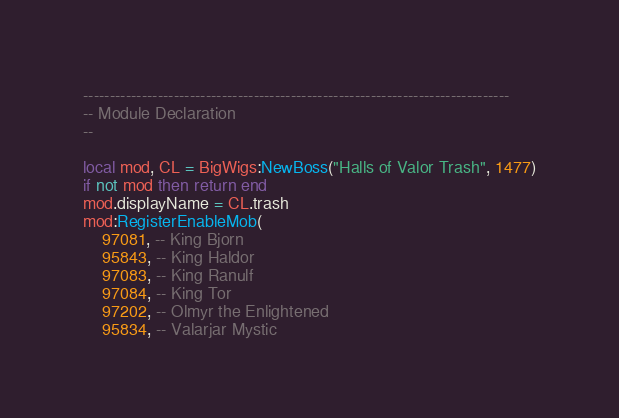<code> <loc_0><loc_0><loc_500><loc_500><_Lua_>
--------------------------------------------------------------------------------
-- Module Declaration
--

local mod, CL = BigWigs:NewBoss("Halls of Valor Trash", 1477)
if not mod then return end
mod.displayName = CL.trash
mod:RegisterEnableMob(
	97081, -- King Bjorn
	95843, -- King Haldor
	97083, -- King Ranulf
	97084, -- King Tor
	97202, -- Olmyr the Enlightened
	95834, -- Valarjar Mystic</code> 